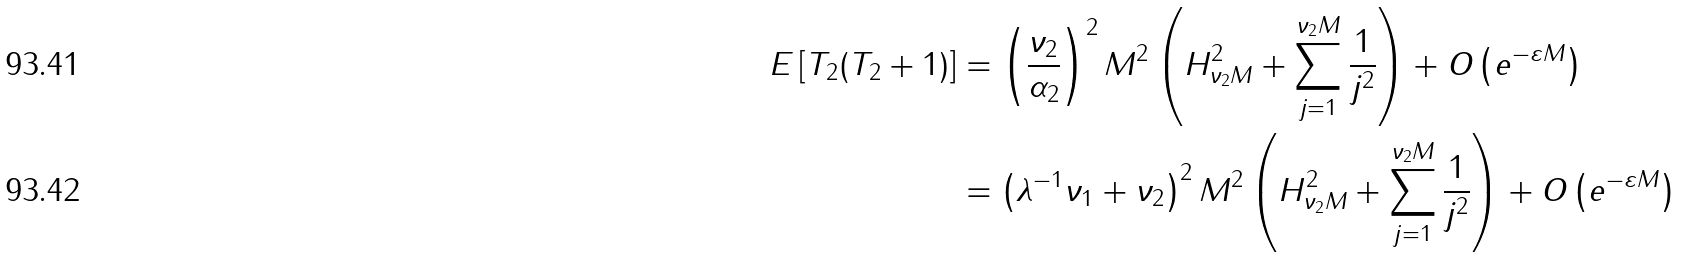<formula> <loc_0><loc_0><loc_500><loc_500>E \left [ T _ { 2 } ( T _ { 2 } + 1 ) \right ] & = \left ( \frac { \nu _ { 2 } } { \alpha _ { 2 } } \right ) ^ { 2 } M ^ { 2 } \left ( H _ { \nu _ { 2 } M } ^ { 2 } + \sum _ { j = 1 } ^ { \nu _ { 2 } M } \frac { 1 } { j ^ { 2 } } \right ) + O \left ( e ^ { - \varepsilon M } \right ) \\ & = \left ( \lambda ^ { - 1 } \nu _ { 1 } + \nu _ { 2 } \right ) ^ { 2 } M ^ { 2 } \left ( H _ { \nu _ { 2 } M } ^ { 2 } + \sum _ { j = 1 } ^ { \nu _ { 2 } M } \frac { 1 } { j ^ { 2 } } \right ) + O \left ( e ^ { - \varepsilon M } \right )</formula> 